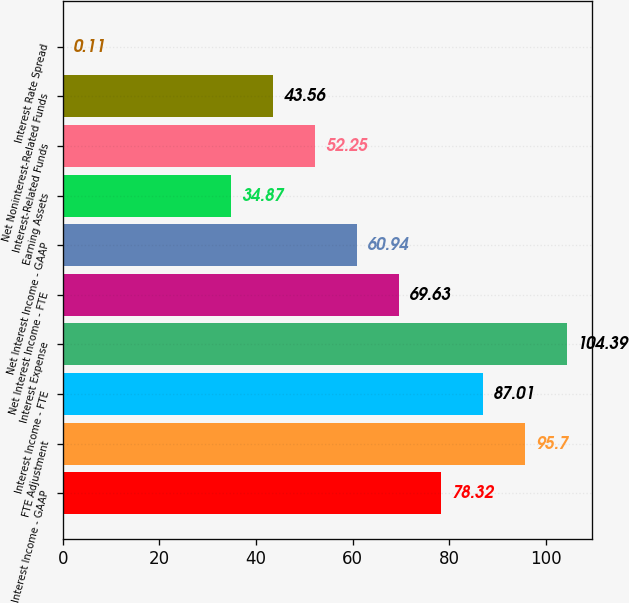Convert chart to OTSL. <chart><loc_0><loc_0><loc_500><loc_500><bar_chart><fcel>Interest Income - GAAP<fcel>FTE Adjustment<fcel>Interest Income - FTE<fcel>Interest Expense<fcel>Net Interest Income - FTE<fcel>Net Interest Income - GAAP<fcel>Earning Assets<fcel>Interest-Related Funds<fcel>Net Noninterest-Related Funds<fcel>Interest Rate Spread<nl><fcel>78.32<fcel>95.7<fcel>87.01<fcel>104.39<fcel>69.63<fcel>60.94<fcel>34.87<fcel>52.25<fcel>43.56<fcel>0.11<nl></chart> 